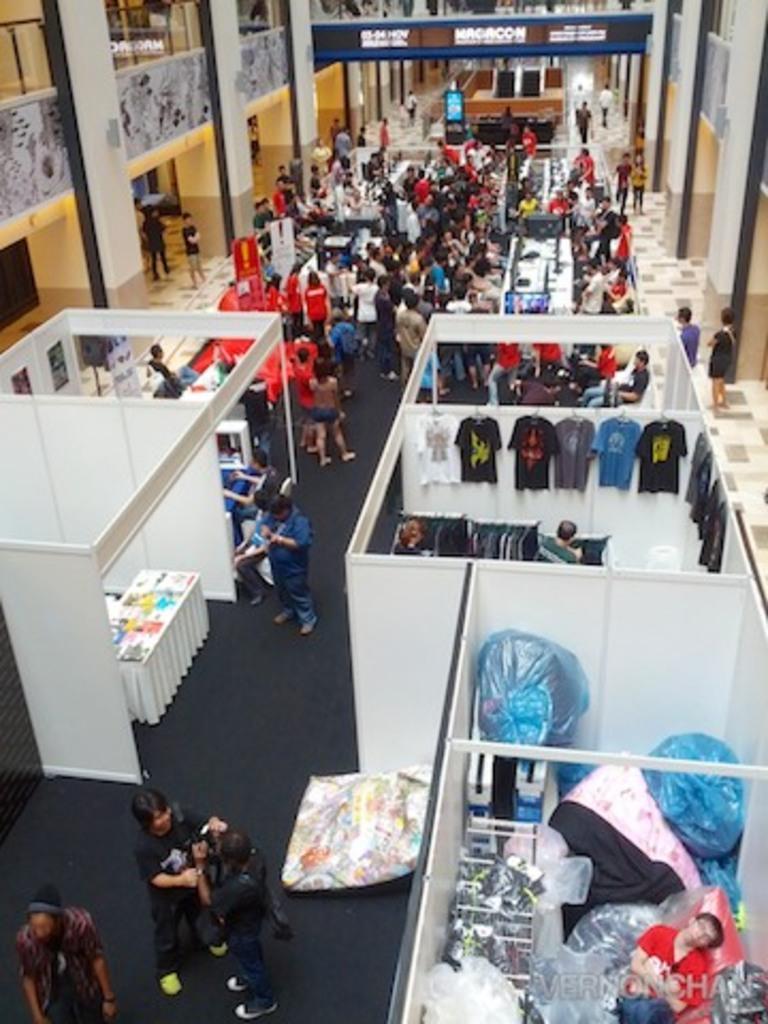In one or two sentences, can you explain what this image depicts? In the image there are many stores and also there are many people standing on the floor. In the background there are pillars and walls with posters. 